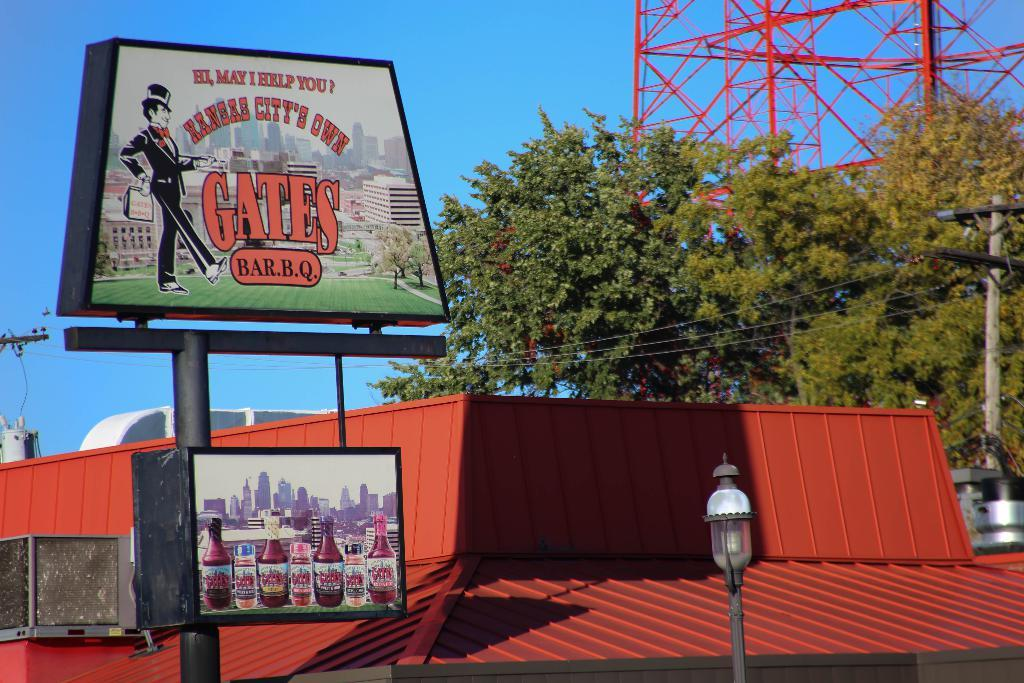<image>
Write a terse but informative summary of the picture. Advertisement sign on the Kansas City's Own Gates Bar BQ. 